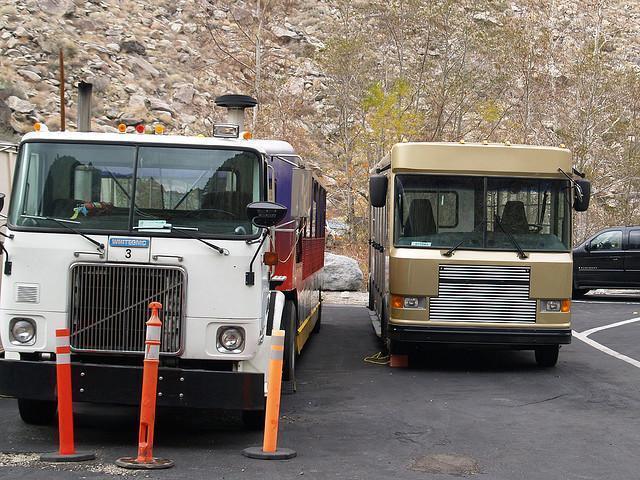What are these vehicles called?
Answer the question by selecting the correct answer among the 4 following choices and explain your choice with a short sentence. The answer should be formatted with the following format: `Answer: choice
Rationale: rationale.`
Options: Planes, cars, tanks, buses. Answer: buses.
Rationale: The vehicles are larger than cars, but not on tracks like tanks.  they are on the ground, not in the air. 